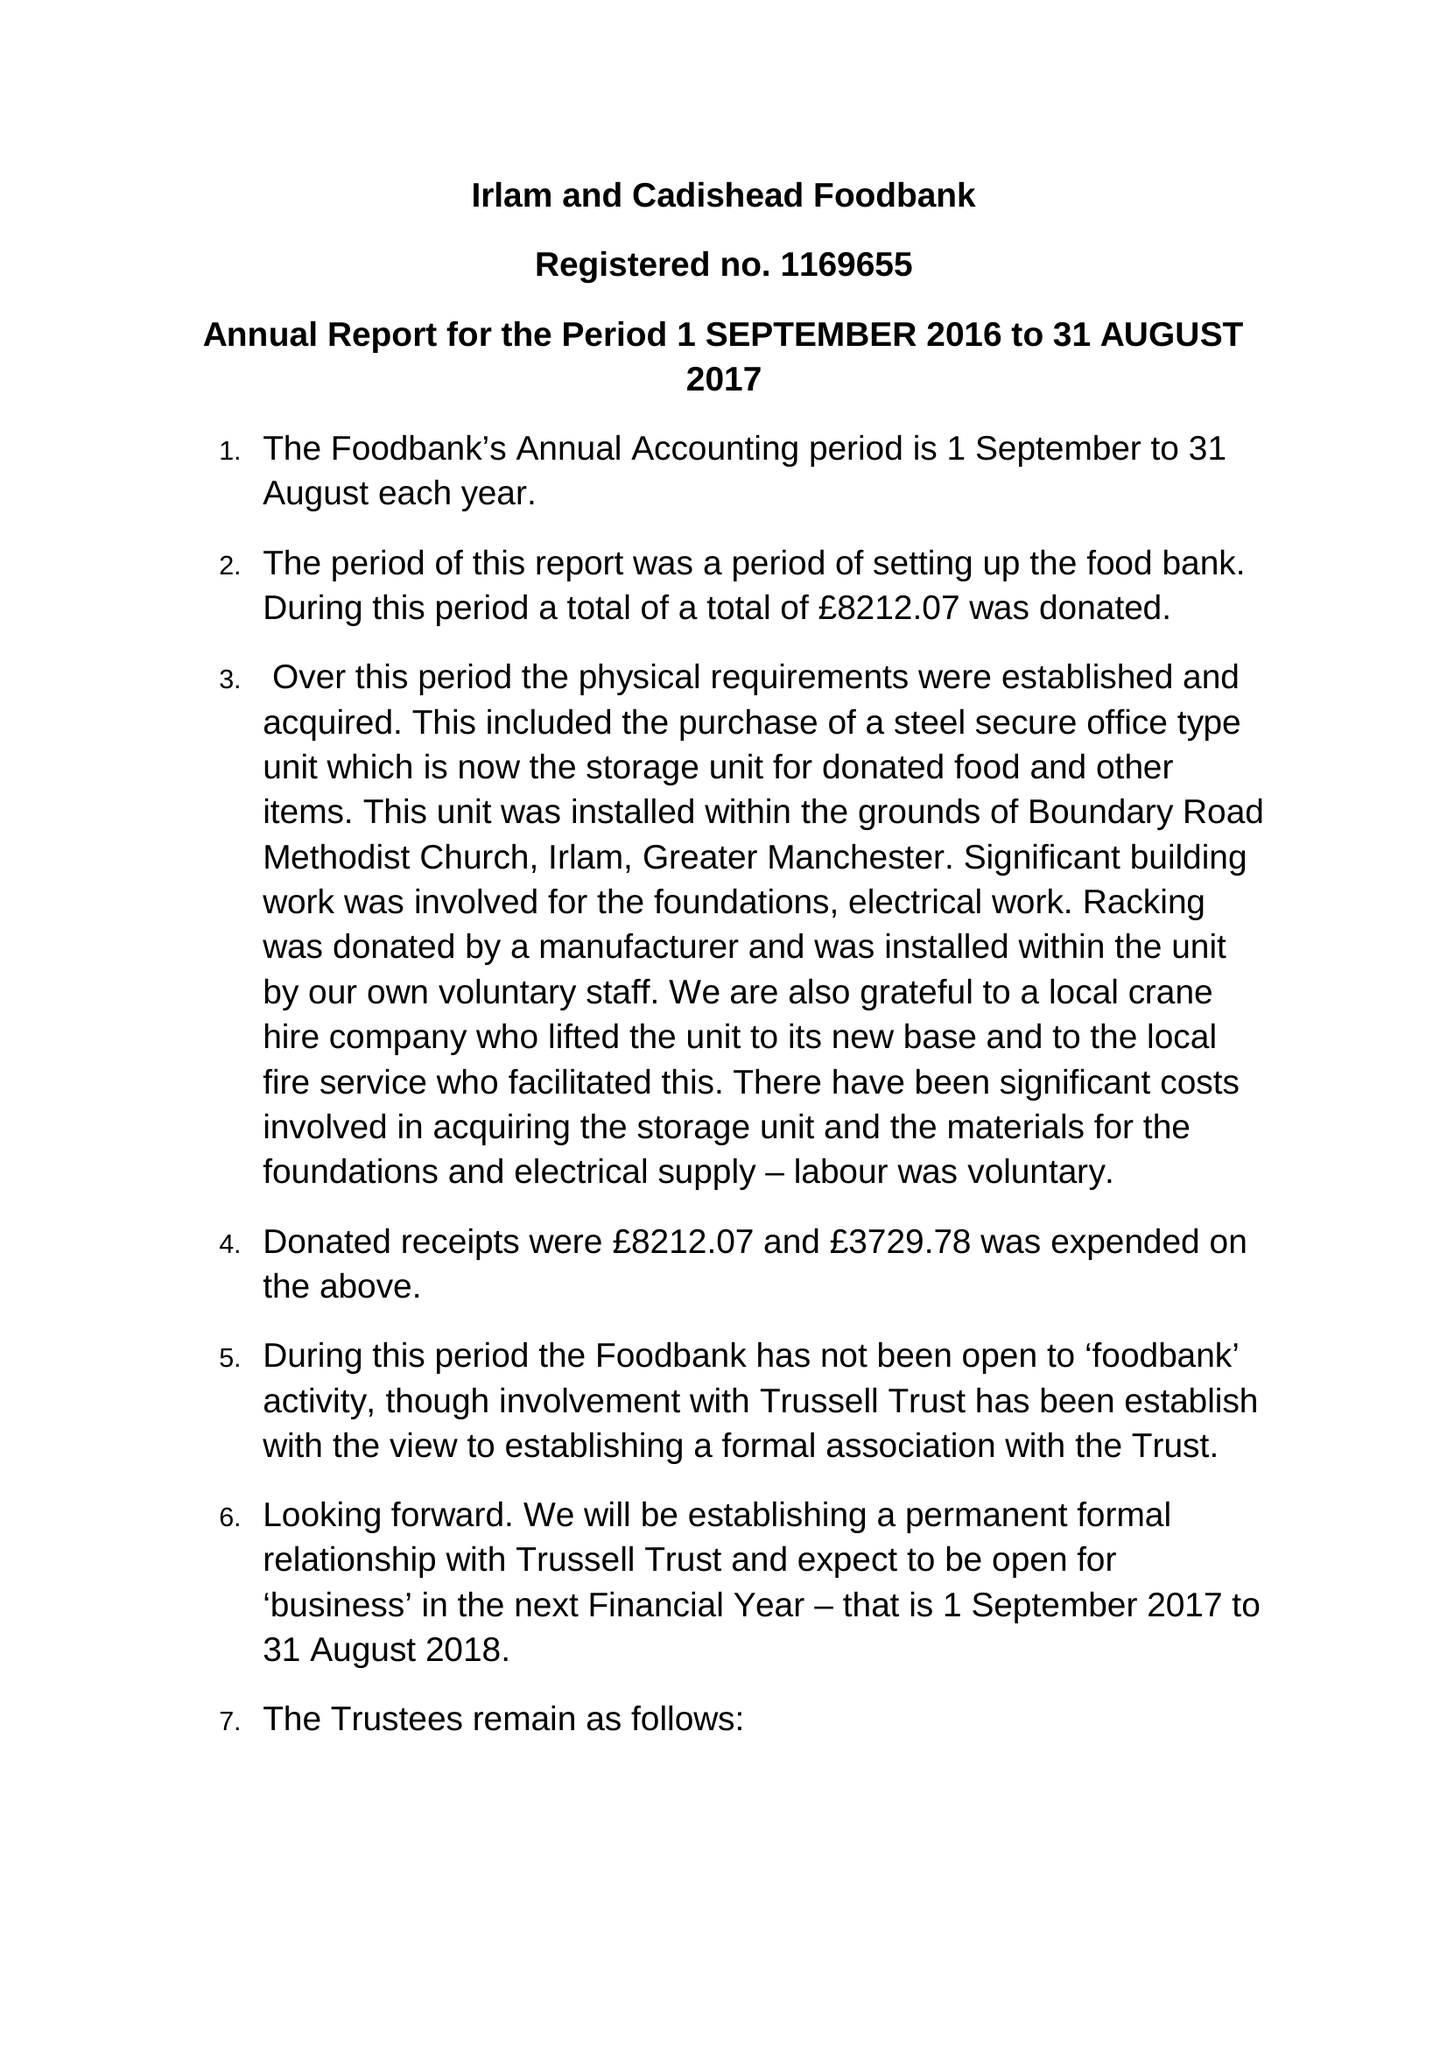What is the value for the address__street_line?
Answer the question using a single word or phrase. BOUNDARY ROAD 